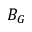Convert formula to latex. <formula><loc_0><loc_0><loc_500><loc_500>B _ { G }</formula> 